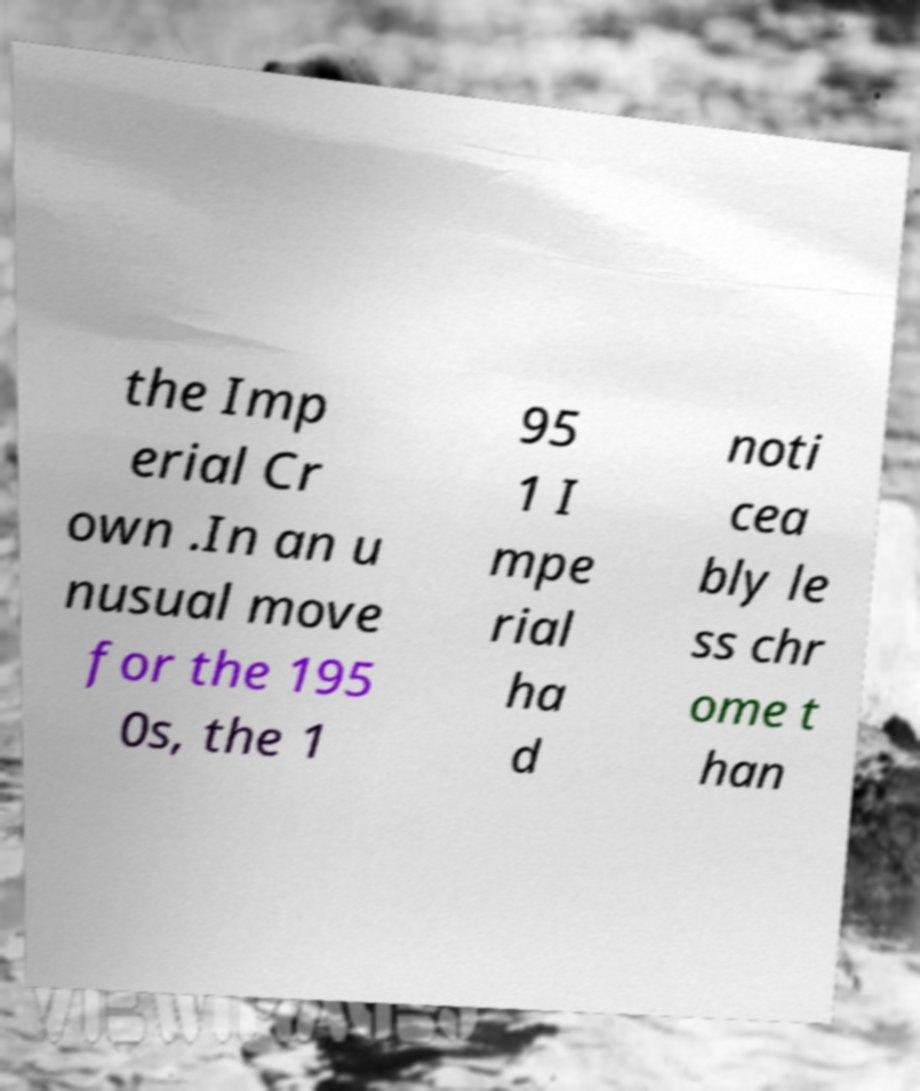I need the written content from this picture converted into text. Can you do that? the Imp erial Cr own .In an u nusual move for the 195 0s, the 1 95 1 I mpe rial ha d noti cea bly le ss chr ome t han 